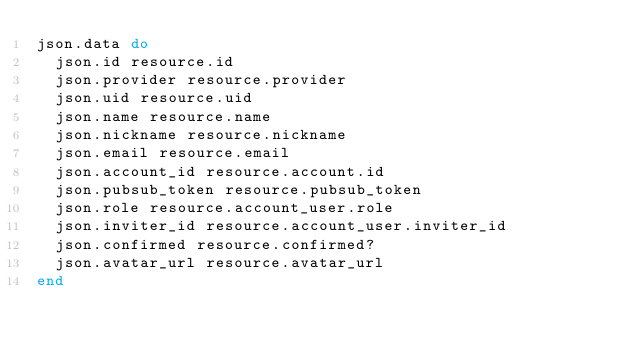Convert code to text. <code><loc_0><loc_0><loc_500><loc_500><_Ruby_>json.data do
  json.id resource.id
  json.provider resource.provider
  json.uid resource.uid
  json.name resource.name
  json.nickname resource.nickname
  json.email resource.email
  json.account_id resource.account.id
  json.pubsub_token resource.pubsub_token
  json.role resource.account_user.role
  json.inviter_id resource.account_user.inviter_id
  json.confirmed resource.confirmed?
  json.avatar_url resource.avatar_url
end
</code> 